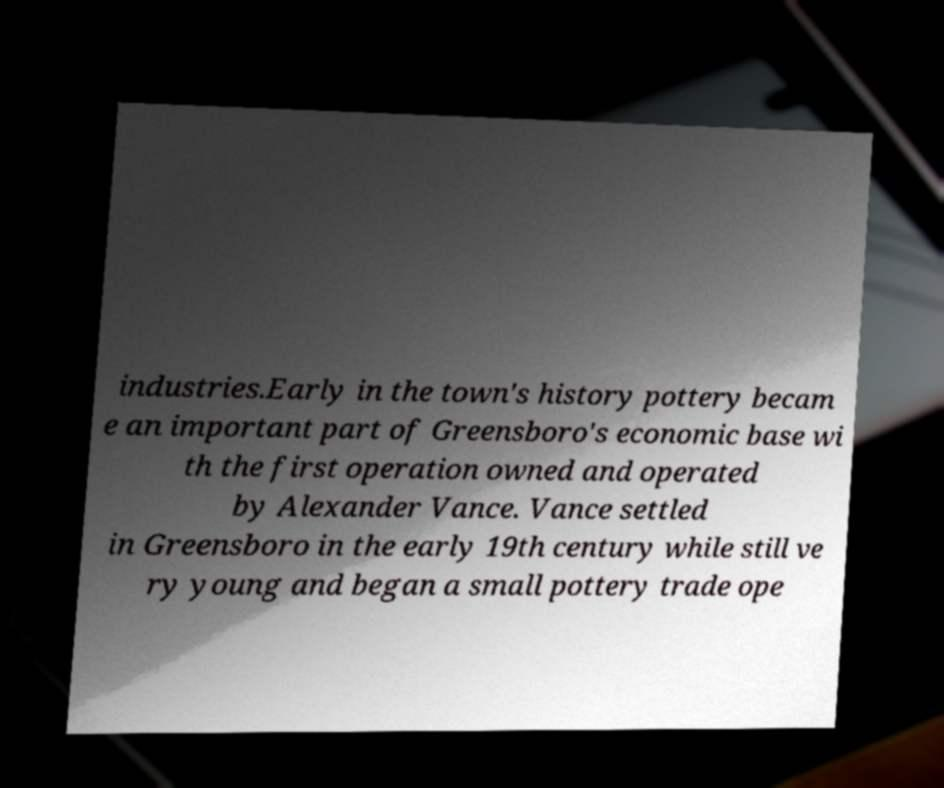What messages or text are displayed in this image? I need them in a readable, typed format. industries.Early in the town's history pottery becam e an important part of Greensboro's economic base wi th the first operation owned and operated by Alexander Vance. Vance settled in Greensboro in the early 19th century while still ve ry young and began a small pottery trade ope 